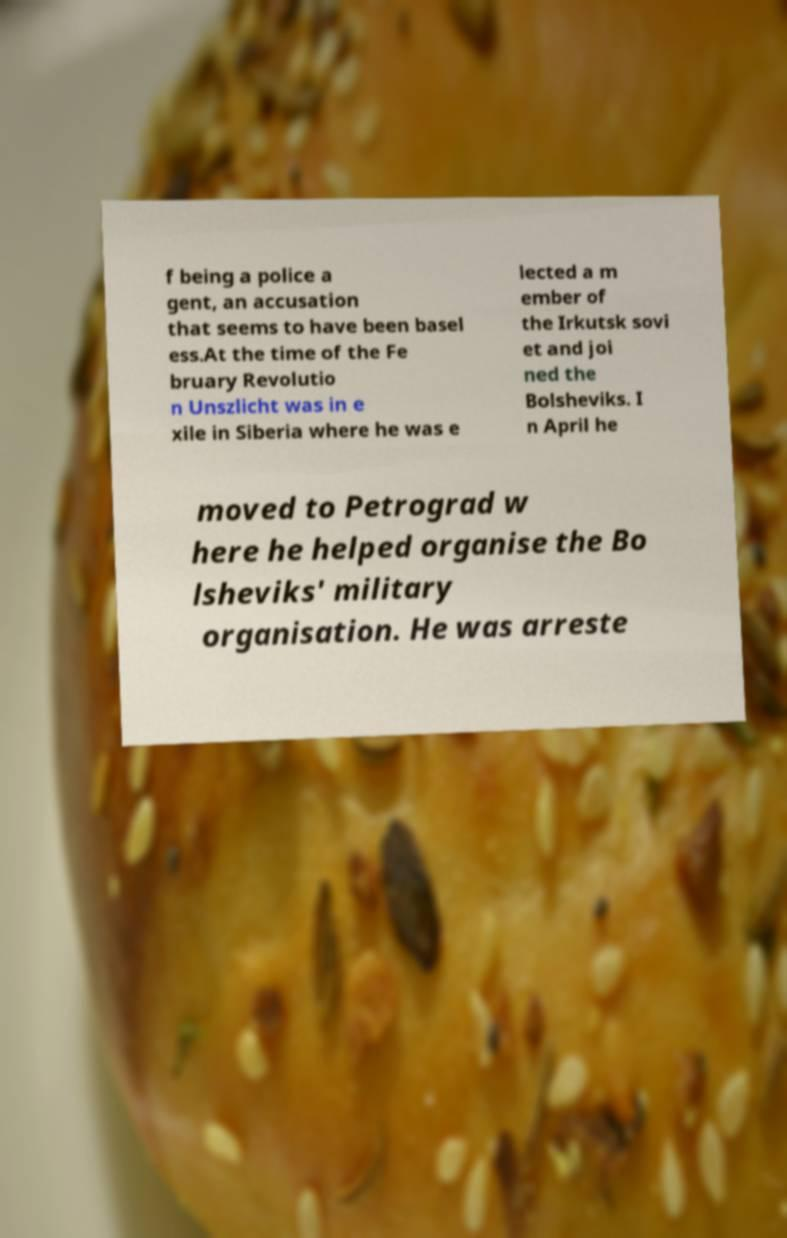Could you extract and type out the text from this image? f being a police a gent, an accusation that seems to have been basel ess.At the time of the Fe bruary Revolutio n Unszlicht was in e xile in Siberia where he was e lected a m ember of the Irkutsk sovi et and joi ned the Bolsheviks. I n April he moved to Petrograd w here he helped organise the Bo lsheviks' military organisation. He was arreste 